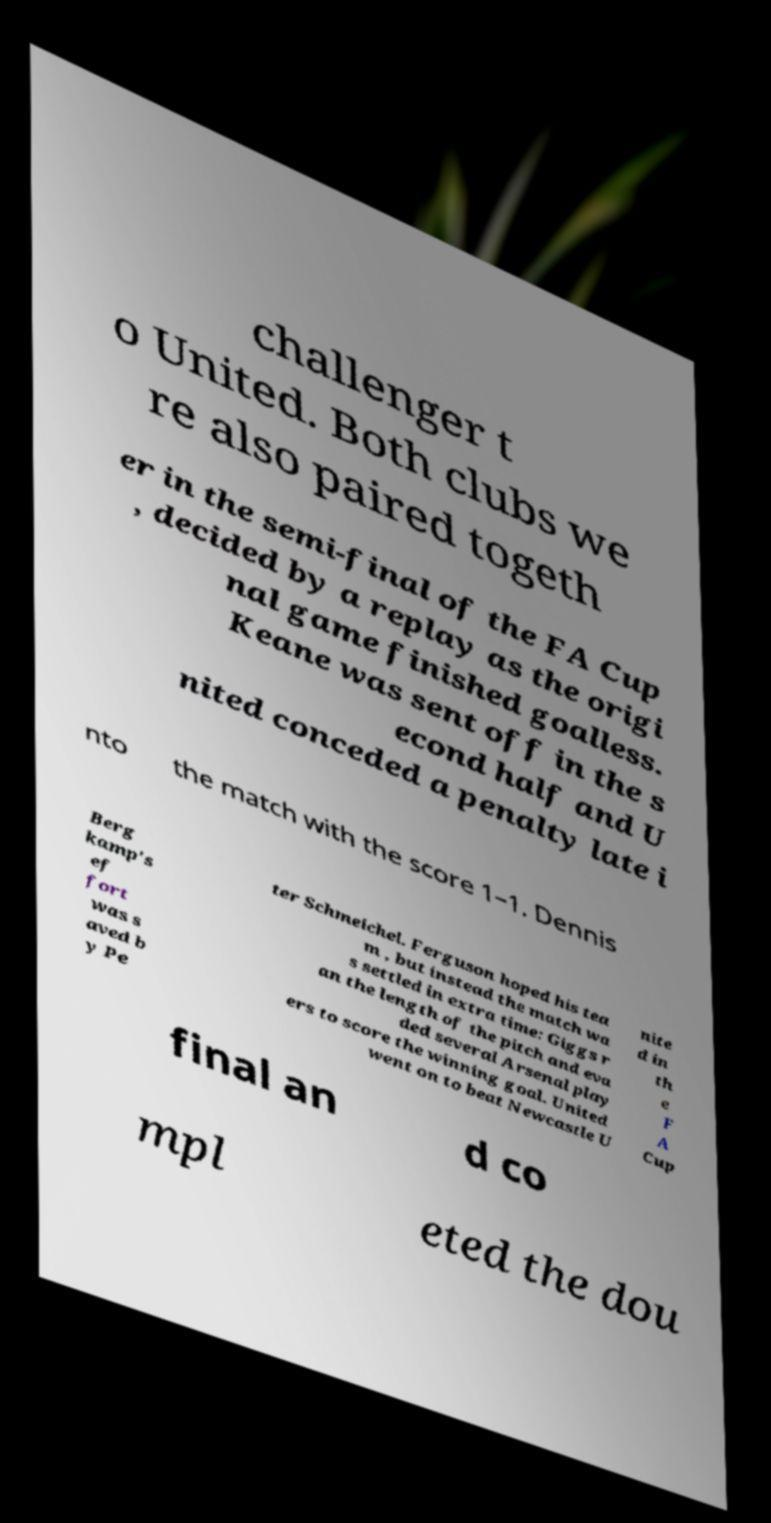I need the written content from this picture converted into text. Can you do that? challenger t o United. Both clubs we re also paired togeth er in the semi-final of the FA Cup , decided by a replay as the origi nal game finished goalless. Keane was sent off in the s econd half and U nited conceded a penalty late i nto the match with the score 1–1. Dennis Berg kamp's ef fort was s aved b y Pe ter Schmeichel. Ferguson hoped his tea m , but instead the match wa s settled in extra time: Giggs r an the length of the pitch and eva ded several Arsenal play ers to score the winning goal. United went on to beat Newcastle U nite d in th e F A Cup final an d co mpl eted the dou 